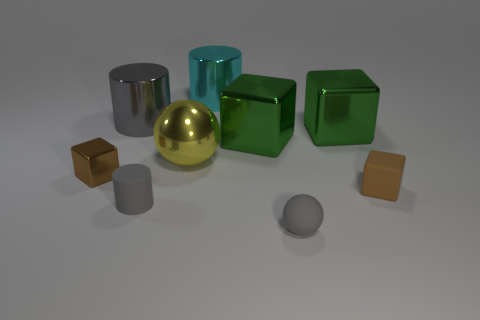Is the number of gray metallic objects in front of the tiny matte cube the same as the number of red spheres?
Offer a very short reply. Yes. There is a tiny block right of the brown object that is left of the brown rubber cube; are there any gray matte cylinders behind it?
Provide a short and direct response. No. What is the cyan cylinder made of?
Your answer should be compact. Metal. How many other things are the same shape as the brown metal thing?
Make the answer very short. 3. Is the shape of the yellow thing the same as the large gray object?
Make the answer very short. No. What number of objects are either tiny gray things that are on the right side of the yellow metallic sphere or metallic blocks that are to the right of the brown shiny thing?
Make the answer very short. 3. How many objects are either small metallic cubes or small rubber objects?
Ensure brevity in your answer.  4. How many tiny gray matte balls are on the right side of the small brown object that is to the left of the large cyan thing?
Offer a terse response. 1. What number of other objects are there of the same size as the rubber ball?
Your response must be concise. 3. What is the size of the other cylinder that is the same color as the small cylinder?
Make the answer very short. Large. 